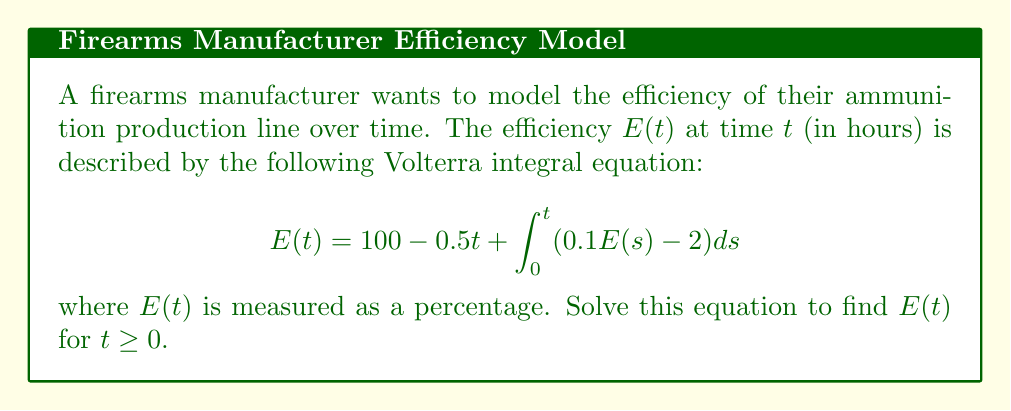Help me with this question. Let's solve this Volterra integral equation step by step:

1) First, we differentiate both sides of the equation with respect to $t$:

   $$\frac{d}{dt}E(t) = -0.5 + \frac{d}{dt}\int_0^t (0.1E(s) - 2) ds$$

2) Using the fundamental theorem of calculus, we get:

   $$\frac{d}{dt}E(t) = -0.5 + (0.1E(t) - 2)$$

3) Rearrange the equation:

   $$\frac{d}{dt}E(t) - 0.1E(t) = -2.5$$

4) This is a first-order linear differential equation. We can solve it using the integrating factor method.

5) The integrating factor is $e^{-0.1t}$. Multiply both sides by this:

   $$e^{-0.1t}\frac{d}{dt}E(t) - 0.1e^{-0.1t}E(t) = -2.5e^{-0.1t}$$

6) The left side is now the derivative of $e^{-0.1t}E(t)$:

   $$\frac{d}{dt}(e^{-0.1t}E(t)) = -2.5e^{-0.1t}$$

7) Integrate both sides:

   $$e^{-0.1t}E(t) = 25e^{-0.1t} + C$$

8) Solve for $E(t)$:

   $$E(t) = 25 + Ce^{0.1t}$$

9) Use the initial condition $E(0) = 100$ to find $C$:

   $$100 = 25 + C \implies C = 75$$

10) Therefore, the solution is:

    $$E(t) = 25 + 75e^{0.1t}$$
Answer: $E(t) = 25 + 75e^{0.1t}$ 